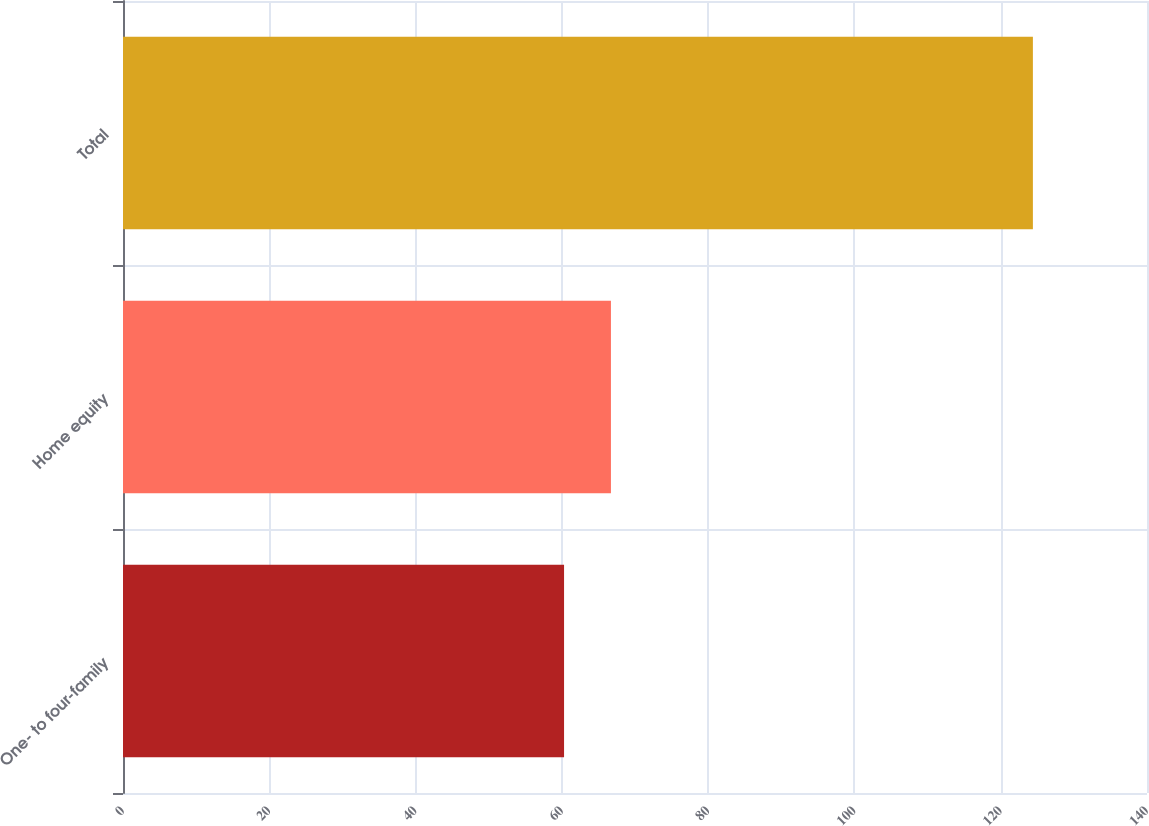Convert chart. <chart><loc_0><loc_0><loc_500><loc_500><bar_chart><fcel>One- to four-family<fcel>Home equity<fcel>Total<nl><fcel>60.3<fcel>66.71<fcel>124.4<nl></chart> 